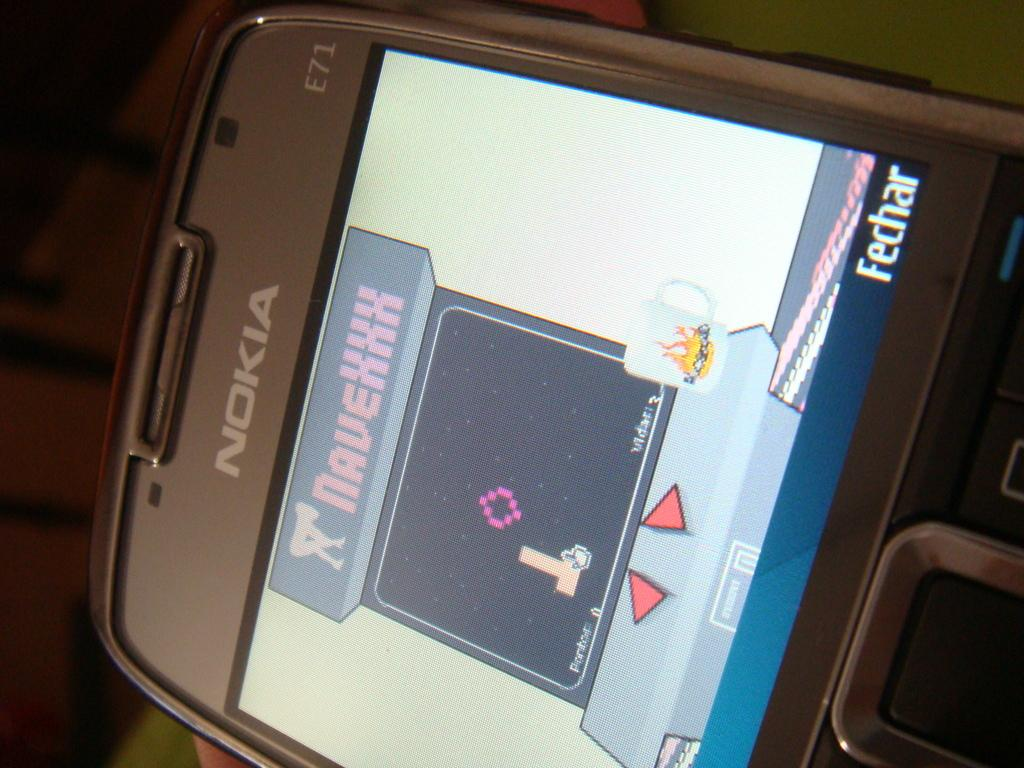<image>
Describe the image concisely. a Nokia phone with a screen of game NaveXXX showing 